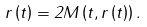<formula> <loc_0><loc_0><loc_500><loc_500>r \left ( t \right ) = 2 M \left ( t , r \left ( t \right ) \right ) .</formula> 